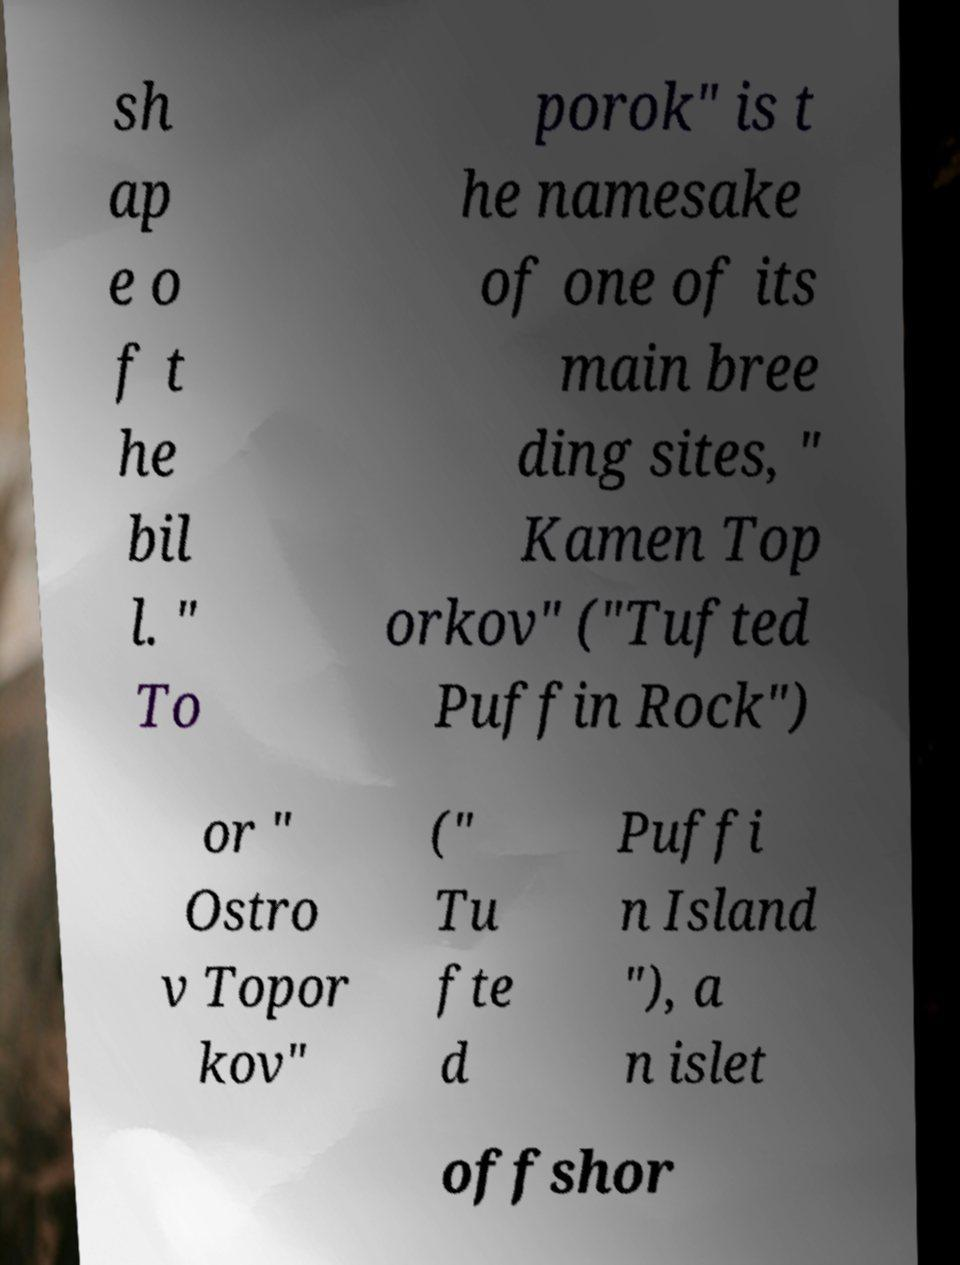There's text embedded in this image that I need extracted. Can you transcribe it verbatim? sh ap e o f t he bil l. " To porok" is t he namesake of one of its main bree ding sites, " Kamen Top orkov" ("Tufted Puffin Rock") or " Ostro v Topor kov" (" Tu fte d Puffi n Island "), a n islet offshor 